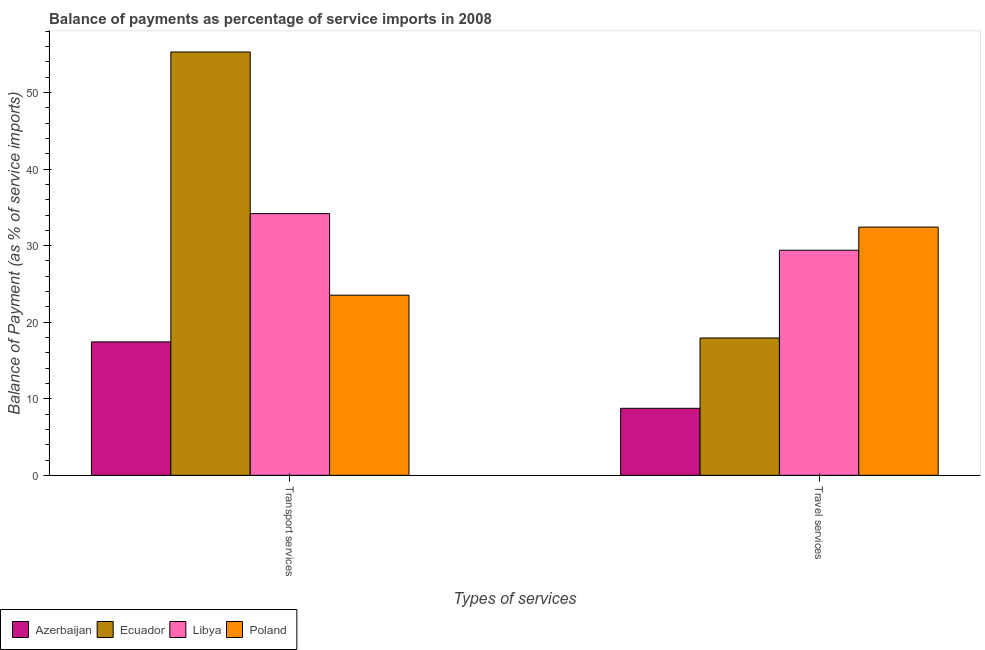Are the number of bars per tick equal to the number of legend labels?
Keep it short and to the point. Yes. What is the label of the 1st group of bars from the left?
Ensure brevity in your answer.  Transport services. What is the balance of payments of travel services in Libya?
Keep it short and to the point. 29.4. Across all countries, what is the maximum balance of payments of travel services?
Your response must be concise. 32.42. Across all countries, what is the minimum balance of payments of transport services?
Give a very brief answer. 17.43. In which country was the balance of payments of travel services minimum?
Your answer should be very brief. Azerbaijan. What is the total balance of payments of travel services in the graph?
Your answer should be very brief. 88.52. What is the difference between the balance of payments of travel services in Poland and that in Libya?
Make the answer very short. 3.02. What is the difference between the balance of payments of transport services in Libya and the balance of payments of travel services in Poland?
Make the answer very short. 1.76. What is the average balance of payments of transport services per country?
Offer a terse response. 32.61. What is the difference between the balance of payments of transport services and balance of payments of travel services in Libya?
Your answer should be very brief. 4.78. In how many countries, is the balance of payments of travel services greater than 54 %?
Make the answer very short. 0. What is the ratio of the balance of payments of travel services in Poland to that in Libya?
Ensure brevity in your answer.  1.1. Is the balance of payments of travel services in Poland less than that in Ecuador?
Make the answer very short. No. In how many countries, is the balance of payments of travel services greater than the average balance of payments of travel services taken over all countries?
Your response must be concise. 2. What does the 3rd bar from the left in Transport services represents?
Ensure brevity in your answer.  Libya. What does the 4th bar from the right in Transport services represents?
Your answer should be very brief. Azerbaijan. How many countries are there in the graph?
Offer a terse response. 4. Are the values on the major ticks of Y-axis written in scientific E-notation?
Give a very brief answer. No. Does the graph contain any zero values?
Provide a succinct answer. No. What is the title of the graph?
Your answer should be compact. Balance of payments as percentage of service imports in 2008. Does "Benin" appear as one of the legend labels in the graph?
Offer a terse response. No. What is the label or title of the X-axis?
Offer a terse response. Types of services. What is the label or title of the Y-axis?
Provide a succinct answer. Balance of Payment (as % of service imports). What is the Balance of Payment (as % of service imports) in Azerbaijan in Transport services?
Your response must be concise. 17.43. What is the Balance of Payment (as % of service imports) of Ecuador in Transport services?
Offer a very short reply. 55.29. What is the Balance of Payment (as % of service imports) in Libya in Transport services?
Provide a short and direct response. 34.18. What is the Balance of Payment (as % of service imports) of Poland in Transport services?
Ensure brevity in your answer.  23.53. What is the Balance of Payment (as % of service imports) of Azerbaijan in Travel services?
Make the answer very short. 8.75. What is the Balance of Payment (as % of service imports) in Ecuador in Travel services?
Offer a terse response. 17.94. What is the Balance of Payment (as % of service imports) in Libya in Travel services?
Offer a very short reply. 29.4. What is the Balance of Payment (as % of service imports) in Poland in Travel services?
Offer a very short reply. 32.42. Across all Types of services, what is the maximum Balance of Payment (as % of service imports) of Azerbaijan?
Offer a terse response. 17.43. Across all Types of services, what is the maximum Balance of Payment (as % of service imports) in Ecuador?
Your answer should be compact. 55.29. Across all Types of services, what is the maximum Balance of Payment (as % of service imports) of Libya?
Your answer should be compact. 34.18. Across all Types of services, what is the maximum Balance of Payment (as % of service imports) of Poland?
Your answer should be compact. 32.42. Across all Types of services, what is the minimum Balance of Payment (as % of service imports) of Azerbaijan?
Provide a succinct answer. 8.75. Across all Types of services, what is the minimum Balance of Payment (as % of service imports) of Ecuador?
Provide a short and direct response. 17.94. Across all Types of services, what is the minimum Balance of Payment (as % of service imports) in Libya?
Your answer should be compact. 29.4. Across all Types of services, what is the minimum Balance of Payment (as % of service imports) of Poland?
Your response must be concise. 23.53. What is the total Balance of Payment (as % of service imports) of Azerbaijan in the graph?
Offer a very short reply. 26.18. What is the total Balance of Payment (as % of service imports) in Ecuador in the graph?
Your answer should be compact. 73.23. What is the total Balance of Payment (as % of service imports) of Libya in the graph?
Make the answer very short. 63.59. What is the total Balance of Payment (as % of service imports) of Poland in the graph?
Provide a succinct answer. 55.95. What is the difference between the Balance of Payment (as % of service imports) of Azerbaijan in Transport services and that in Travel services?
Provide a short and direct response. 8.68. What is the difference between the Balance of Payment (as % of service imports) of Ecuador in Transport services and that in Travel services?
Your response must be concise. 37.35. What is the difference between the Balance of Payment (as % of service imports) in Libya in Transport services and that in Travel services?
Make the answer very short. 4.78. What is the difference between the Balance of Payment (as % of service imports) in Poland in Transport services and that in Travel services?
Offer a very short reply. -8.89. What is the difference between the Balance of Payment (as % of service imports) of Azerbaijan in Transport services and the Balance of Payment (as % of service imports) of Ecuador in Travel services?
Offer a very short reply. -0.51. What is the difference between the Balance of Payment (as % of service imports) of Azerbaijan in Transport services and the Balance of Payment (as % of service imports) of Libya in Travel services?
Give a very brief answer. -11.97. What is the difference between the Balance of Payment (as % of service imports) in Azerbaijan in Transport services and the Balance of Payment (as % of service imports) in Poland in Travel services?
Your answer should be very brief. -14.99. What is the difference between the Balance of Payment (as % of service imports) in Ecuador in Transport services and the Balance of Payment (as % of service imports) in Libya in Travel services?
Give a very brief answer. 25.89. What is the difference between the Balance of Payment (as % of service imports) in Ecuador in Transport services and the Balance of Payment (as % of service imports) in Poland in Travel services?
Give a very brief answer. 22.87. What is the difference between the Balance of Payment (as % of service imports) in Libya in Transport services and the Balance of Payment (as % of service imports) in Poland in Travel services?
Your response must be concise. 1.76. What is the average Balance of Payment (as % of service imports) of Azerbaijan per Types of services?
Keep it short and to the point. 13.09. What is the average Balance of Payment (as % of service imports) of Ecuador per Types of services?
Provide a succinct answer. 36.62. What is the average Balance of Payment (as % of service imports) of Libya per Types of services?
Offer a very short reply. 31.79. What is the average Balance of Payment (as % of service imports) in Poland per Types of services?
Provide a short and direct response. 27.98. What is the difference between the Balance of Payment (as % of service imports) of Azerbaijan and Balance of Payment (as % of service imports) of Ecuador in Transport services?
Offer a terse response. -37.86. What is the difference between the Balance of Payment (as % of service imports) of Azerbaijan and Balance of Payment (as % of service imports) of Libya in Transport services?
Offer a very short reply. -16.75. What is the difference between the Balance of Payment (as % of service imports) of Azerbaijan and Balance of Payment (as % of service imports) of Poland in Transport services?
Keep it short and to the point. -6.1. What is the difference between the Balance of Payment (as % of service imports) in Ecuador and Balance of Payment (as % of service imports) in Libya in Transport services?
Offer a terse response. 21.11. What is the difference between the Balance of Payment (as % of service imports) in Ecuador and Balance of Payment (as % of service imports) in Poland in Transport services?
Provide a short and direct response. 31.76. What is the difference between the Balance of Payment (as % of service imports) of Libya and Balance of Payment (as % of service imports) of Poland in Transport services?
Ensure brevity in your answer.  10.65. What is the difference between the Balance of Payment (as % of service imports) of Azerbaijan and Balance of Payment (as % of service imports) of Ecuador in Travel services?
Make the answer very short. -9.19. What is the difference between the Balance of Payment (as % of service imports) of Azerbaijan and Balance of Payment (as % of service imports) of Libya in Travel services?
Give a very brief answer. -20.65. What is the difference between the Balance of Payment (as % of service imports) in Azerbaijan and Balance of Payment (as % of service imports) in Poland in Travel services?
Your response must be concise. -23.67. What is the difference between the Balance of Payment (as % of service imports) of Ecuador and Balance of Payment (as % of service imports) of Libya in Travel services?
Offer a very short reply. -11.46. What is the difference between the Balance of Payment (as % of service imports) in Ecuador and Balance of Payment (as % of service imports) in Poland in Travel services?
Ensure brevity in your answer.  -14.48. What is the difference between the Balance of Payment (as % of service imports) in Libya and Balance of Payment (as % of service imports) in Poland in Travel services?
Provide a succinct answer. -3.02. What is the ratio of the Balance of Payment (as % of service imports) in Azerbaijan in Transport services to that in Travel services?
Offer a terse response. 1.99. What is the ratio of the Balance of Payment (as % of service imports) of Ecuador in Transport services to that in Travel services?
Make the answer very short. 3.08. What is the ratio of the Balance of Payment (as % of service imports) of Libya in Transport services to that in Travel services?
Ensure brevity in your answer.  1.16. What is the ratio of the Balance of Payment (as % of service imports) of Poland in Transport services to that in Travel services?
Keep it short and to the point. 0.73. What is the difference between the highest and the second highest Balance of Payment (as % of service imports) in Azerbaijan?
Offer a very short reply. 8.68. What is the difference between the highest and the second highest Balance of Payment (as % of service imports) in Ecuador?
Offer a terse response. 37.35. What is the difference between the highest and the second highest Balance of Payment (as % of service imports) of Libya?
Make the answer very short. 4.78. What is the difference between the highest and the second highest Balance of Payment (as % of service imports) of Poland?
Provide a succinct answer. 8.89. What is the difference between the highest and the lowest Balance of Payment (as % of service imports) of Azerbaijan?
Your answer should be compact. 8.68. What is the difference between the highest and the lowest Balance of Payment (as % of service imports) in Ecuador?
Your answer should be compact. 37.35. What is the difference between the highest and the lowest Balance of Payment (as % of service imports) of Libya?
Give a very brief answer. 4.78. What is the difference between the highest and the lowest Balance of Payment (as % of service imports) in Poland?
Provide a short and direct response. 8.89. 